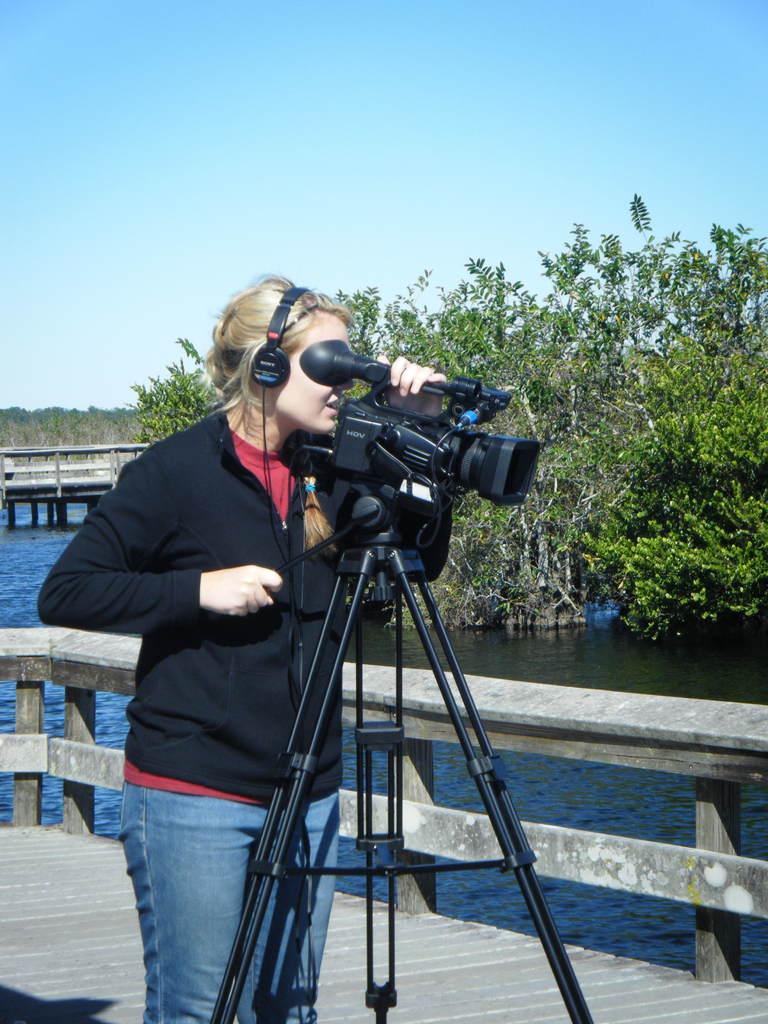How would you summarize this image in a sentence or two? On the left there is a woman standing on the floor by holding a camera with her hand which is on a tripod stand. In the background we can see a platform,trees,water and sky. 